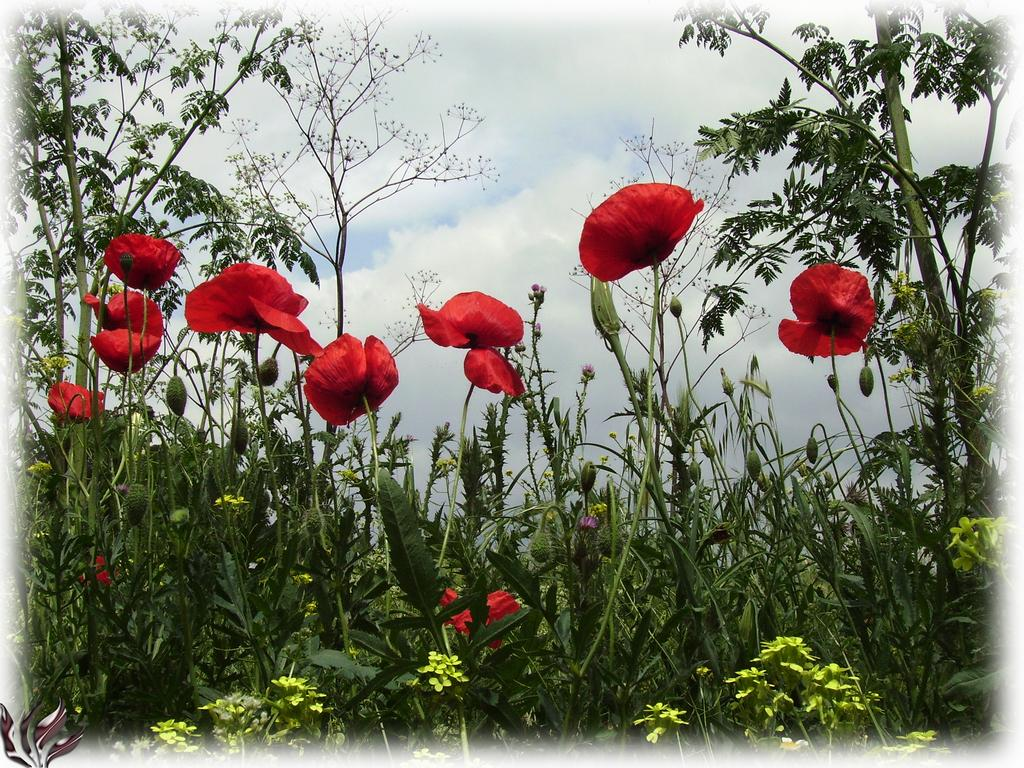What type of flowers can be seen in the image? There are red color flowers in the image. Where are the flowers located? The flowers are on plants. How are the plants positioned in the image? The plants are on the ground. What can be seen in the background of the image? The sky is visible in the background of the image. What is the condition of the sky in the image? There are clouds in the sky. What type of trousers are hanging on the plants in the image? There are no trousers present in the image; it features red color flowers on plants. Can you tell me the price of the corn in the image? There is no corn present in the image, so it is not possible to determine its price. 